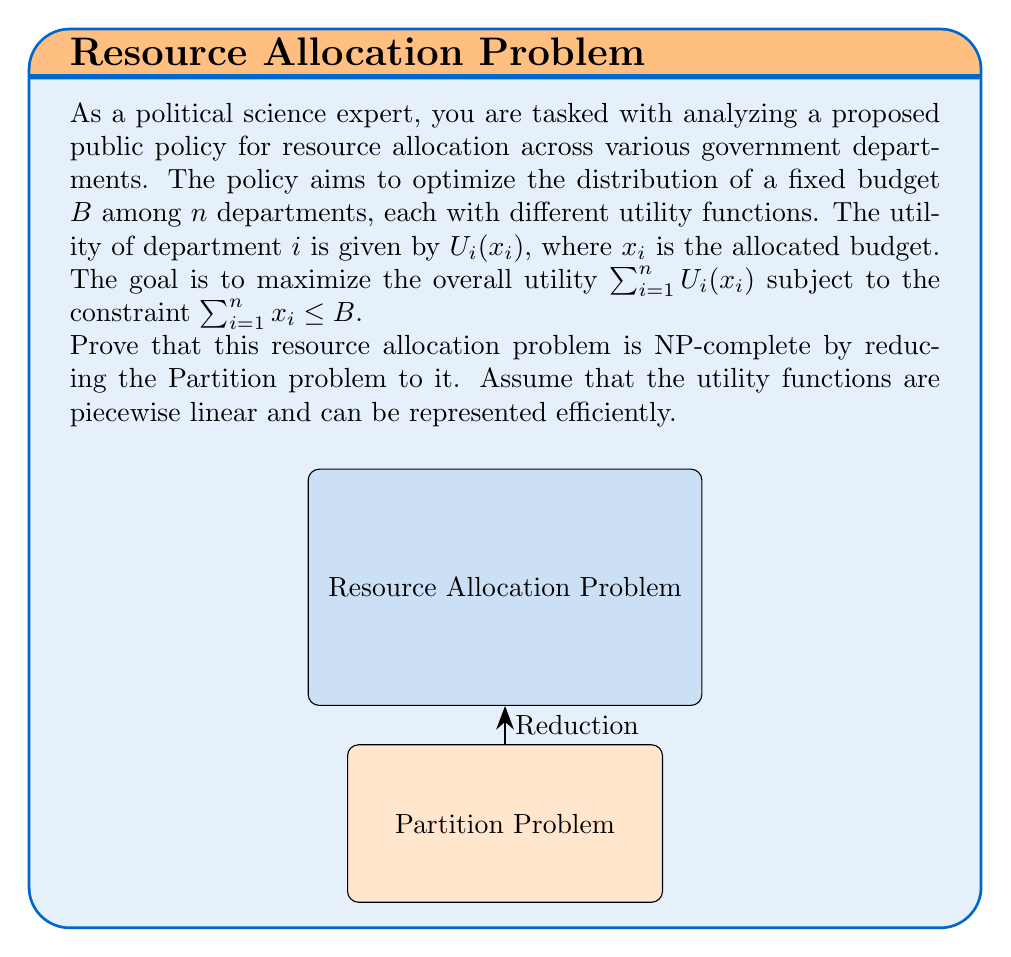Provide a solution to this math problem. To prove that the resource allocation problem is NP-complete, we need to show that:
1. It is in NP
2. A known NP-complete problem can be reduced to it

Step 1: Show the problem is in NP
The resource allocation problem is in NP because given a solution (allocation of resources), we can verify its feasibility and calculate its utility in polynomial time.

Step 2: Reduce the Partition problem to the resource allocation problem
The Partition problem is known to be NP-complete. It asks whether a set of positive integers can be partitioned into two subsets with equal sums.

Reduction:
Given an instance of the Partition problem with a set $S = \{s_1, s_2, ..., s_n\}$, we construct an instance of the resource allocation problem as follows:

1. Set the number of departments $n$ equal to the number of elements in $S$.
2. Set the total budget $B = \frac{1}{2}\sum_{i=1}^n s_i$.
3. Define the utility function for each department $i$ as:

   $$U_i(x_i) = \begin{cases}
   x_i & \text{if } x_i \leq s_i \\
   s_i & \text{if } x_i > s_i
   \end{cases}$$

Now, we claim that the Partition problem has a solution if and only if the resource allocation problem has a solution with total utility equal to $B$.

Proof:
$(\Rightarrow)$ If the Partition problem has a solution, there exists a subset $S' \subset S$ such that $\sum_{s_i \in S'} s_i = \sum_{s_i \in S \setminus S'} s_i = B$. Allocate $x_i = s_i$ for $s_i \in S'$ and $x_i = 0$ for $s_i \in S \setminus S'$. This allocation satisfies the budget constraint and achieves a total utility of $B$.

$(\Leftarrow)$ If the resource allocation problem has a solution with total utility $B$, then for each department $i$, we must have $x_i = s_i$ or $x_i = 0$ (due to the piecewise linear utility functions). The departments with $x_i = s_i$ form a subset $S'$ that solves the Partition problem.

This reduction is polynomial-time, as we can construct the resource allocation instance in $O(n)$ time.

Since we have shown that the problem is in NP and we can reduce a known NP-complete problem to it, we conclude that the resource allocation problem is NP-complete.
Answer: The resource allocation problem is NP-complete. 